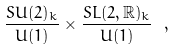<formula> <loc_0><loc_0><loc_500><loc_500>\frac { S U ( 2 ) _ { k } } { U ( 1 ) } \times \frac { S L ( 2 , \mathbb { R } ) _ { k } } { U ( 1 ) } \ ,</formula> 